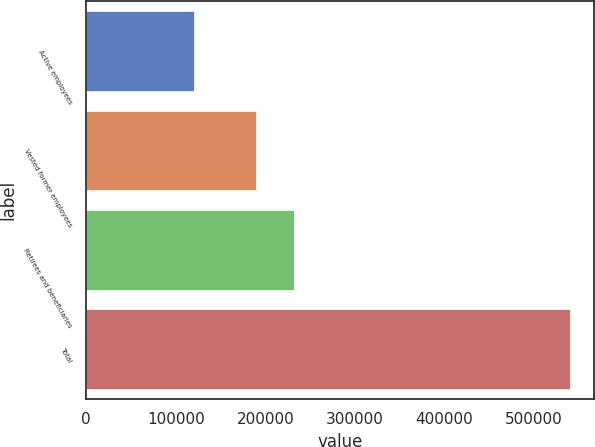Convert chart. <chart><loc_0><loc_0><loc_500><loc_500><bar_chart><fcel>Active employees<fcel>Vested former employees<fcel>Retirees and beneficiaries<fcel>Total<nl><fcel>120000<fcel>190000<fcel>232000<fcel>540000<nl></chart> 